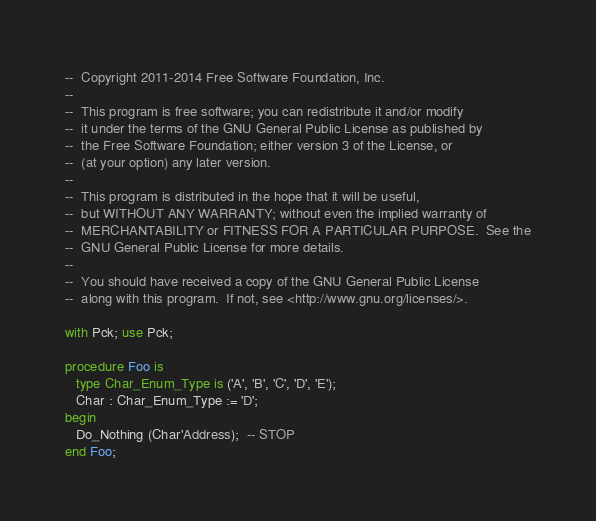Convert code to text. <code><loc_0><loc_0><loc_500><loc_500><_Ada_>--  Copyright 2011-2014 Free Software Foundation, Inc.
--
--  This program is free software; you can redistribute it and/or modify
--  it under the terms of the GNU General Public License as published by
--  the Free Software Foundation; either version 3 of the License, or
--  (at your option) any later version.
--
--  This program is distributed in the hope that it will be useful,
--  but WITHOUT ANY WARRANTY; without even the implied warranty of
--  MERCHANTABILITY or FITNESS FOR A PARTICULAR PURPOSE.  See the
--  GNU General Public License for more details.
--
--  You should have received a copy of the GNU General Public License
--  along with this program.  If not, see <http://www.gnu.org/licenses/>.

with Pck; use Pck;

procedure Foo is
   type Char_Enum_Type is ('A', 'B', 'C', 'D', 'E');
   Char : Char_Enum_Type := 'D';
begin
   Do_Nothing (Char'Address);  -- STOP
end Foo;
</code> 